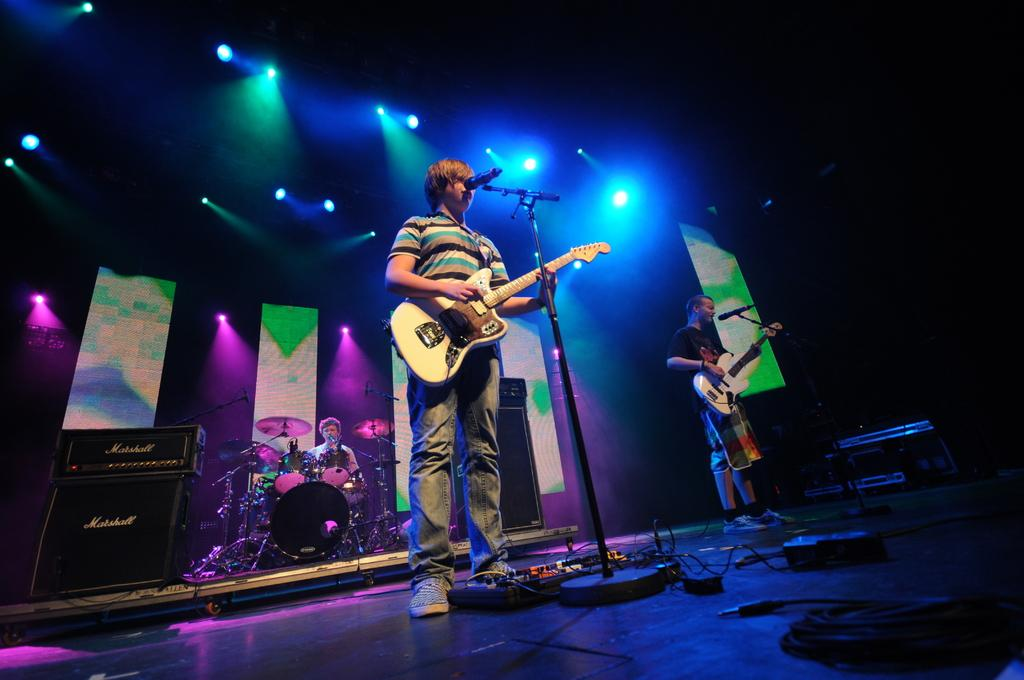What is the main subject of the image? The main subject of the image is a man. What is the man doing in the image? The man is standing and holding guitars in his hand. Can you describe the person in the background of the image? The person in the background is playing drums. What type of sail can be seen in the image? There is no sail present in the image. What company does the man belong to in the image? The image does not provide information about any company affiliations. 